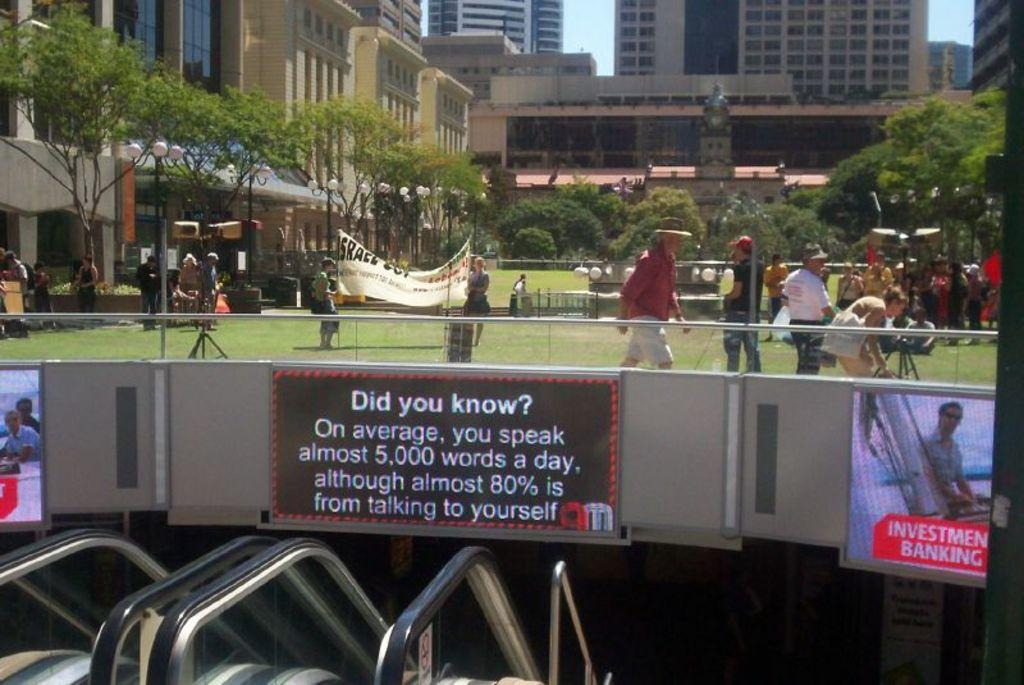What are the people in the image wearing? The people in the image are wearing clothes. Are there any accessories visible on the people? Yes, some people are wearing caps. What can be seen in the image besides people? There is a banner, trees, buildings, windows, grass, and the sky visible in the image. Can you see a kitten playing with a jellyfish in the image? No, there is no kitten or jellyfish present in the image. 